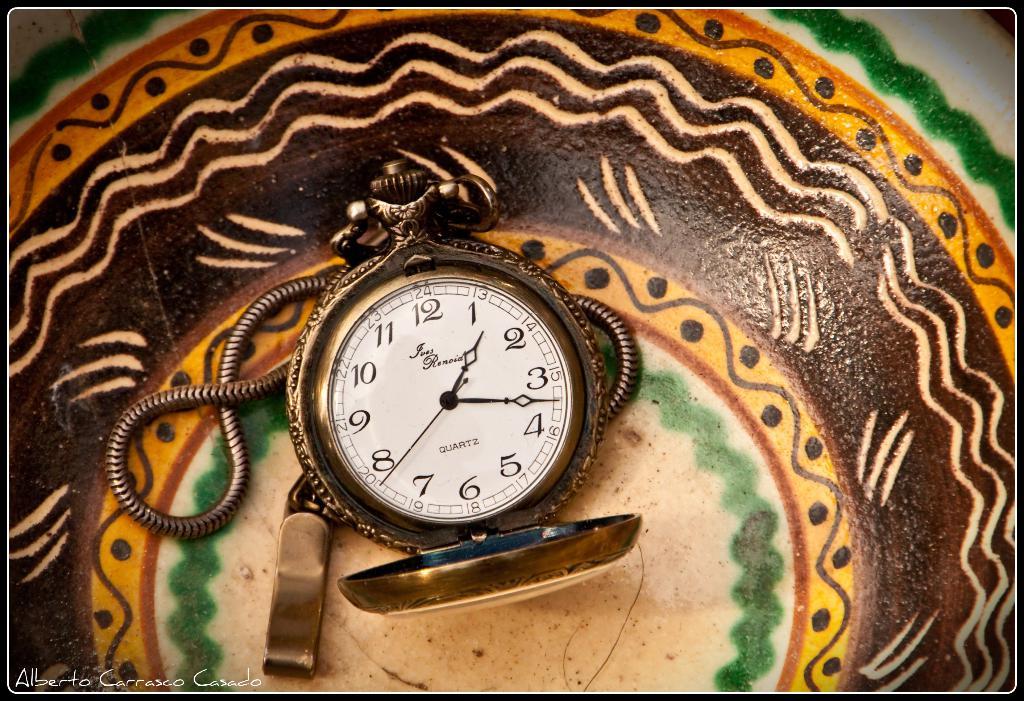What is this time piece made from?
Provide a short and direct response. Quartz. 